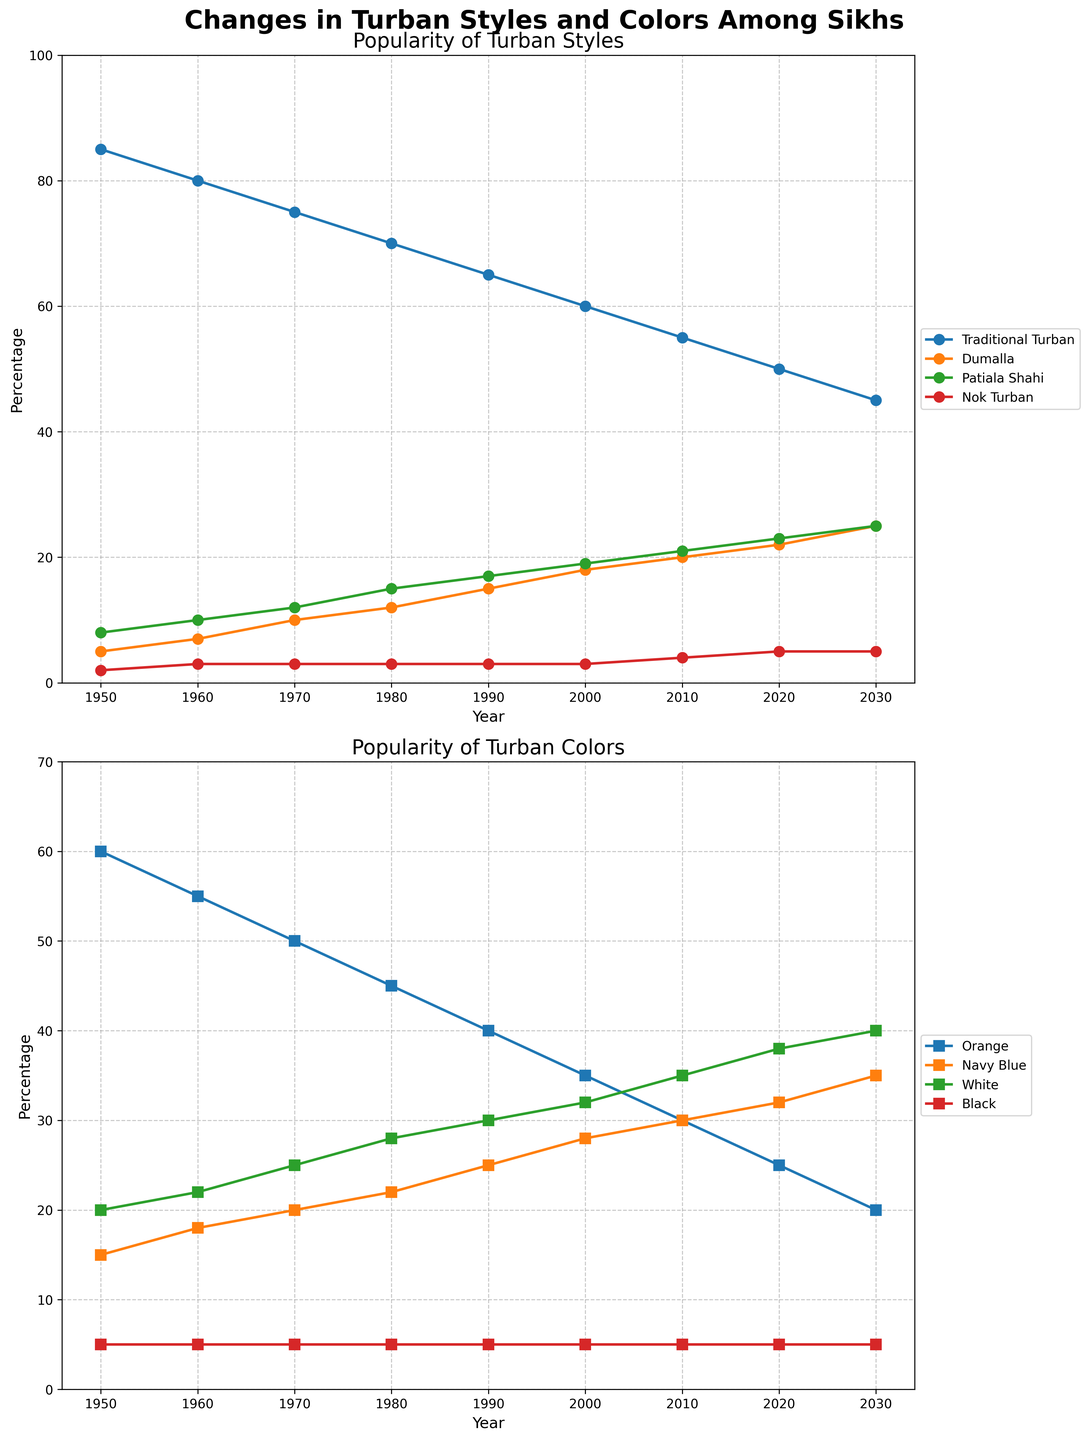Which turban style shows a continuous decrease in popularity from 1950 to 2030? The graph shows four turban styles plotted over the years: Traditional Turban, Dumalla, Patiala Shahi, and Nok Turban. The Traditional Turban shows a continuous decrease in percentage from 1950 to 2030.
Answer: Traditional Turban What is the most popular turban color in 2030? In the second subplot related to turban colors, the graph shows four turban colors: Orange, Navy Blue, White, and Black, each indicated by different markers and colors. In 2030, White has the highest percentage.
Answer: White How does the popularity of Dumalla compare between the years 1970 and 2010? The graph shows the popularity of Dumalla in 1970 as 10% and in 2010 as 20%. The percentage has doubled over this period.
Answer: It doubled Which turban style was introduced gradually and maintained consistent low popularity? Analyzing the turban style trends shows that Nok Turban remained consistently low, starting from 2% in 1950 and slowly rising to 5% by 2030.
Answer: Nok Turban How did the popularity of Orange turban color change from 1950 to 2020? The graph indicates that the popularity of Orange turban color decreased from 60% in 1950 to 25% in 2020.
Answer: It decreased What is the difference in popularity between Traditional Turban and Patiala Shahi in 2000? According to the chart, the popularity percentages in 2000 were 60% for Traditional Turban and 19% for Patiala Shahi. The difference is 60 - 19 = 41%.
Answer: 41% Which turban color had the most significant increase from 1950 to 2030? Examining the graph, Navy Blue increased from 15% in 1950 to 35% in 2030, reflecting a significant increase.
Answer: Navy Blue Between 1980 and 2000, which turban style increased the most in popularity? According to the graph, the increase in percentage for the turban styles from 1980 to 2000 is as follows: Dumalla (12% to 18%), Patiala Shahi (15% to 19%), and others show less change. Thus, Dumalla increased the most.
Answer: Dumalla By how much did the popularity of White turban color grow from 1990 to 2030? The graph shows that the White turban color popularity grew from 30% in 1990 to 40% in 2030. So the difference is 40 - 30 = 10%.
Answer: 10% What is the sum of the popularities of all turban colors in 2010? According to the chart, the popularities of different colors in 2010 are: Orange (30%), Navy Blue (30%), White (35%), and Black (5%). Summing these values gives 30 + 30 + 35 + 5 = 100%.
Answer: 100% 